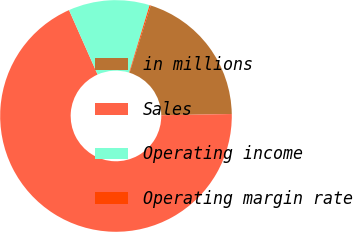<chart> <loc_0><loc_0><loc_500><loc_500><pie_chart><fcel>in millions<fcel>Sales<fcel>Operating income<fcel>Operating margin rate<nl><fcel>19.88%<fcel>68.62%<fcel>11.33%<fcel>0.16%<nl></chart> 